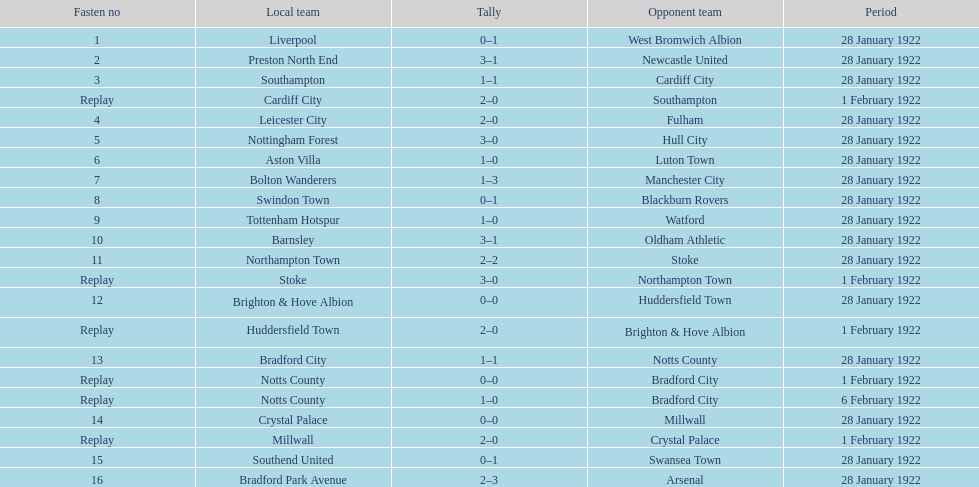What are all of the home teams? Liverpool, Preston North End, Southampton, Cardiff City, Leicester City, Nottingham Forest, Aston Villa, Bolton Wanderers, Swindon Town, Tottenham Hotspur, Barnsley, Northampton Town, Stoke, Brighton & Hove Albion, Huddersfield Town, Bradford City, Notts County, Notts County, Crystal Palace, Millwall, Southend United, Bradford Park Avenue. Could you parse the entire table? {'header': ['Fasten no', 'Local team', 'Tally', 'Opponent team', 'Period'], 'rows': [['1', 'Liverpool', '0–1', 'West Bromwich Albion', '28 January 1922'], ['2', 'Preston North End', '3–1', 'Newcastle United', '28 January 1922'], ['3', 'Southampton', '1–1', 'Cardiff City', '28 January 1922'], ['Replay', 'Cardiff City', '2–0', 'Southampton', '1 February 1922'], ['4', 'Leicester City', '2–0', 'Fulham', '28 January 1922'], ['5', 'Nottingham Forest', '3–0', 'Hull City', '28 January 1922'], ['6', 'Aston Villa', '1–0', 'Luton Town', '28 January 1922'], ['7', 'Bolton Wanderers', '1–3', 'Manchester City', '28 January 1922'], ['8', 'Swindon Town', '0–1', 'Blackburn Rovers', '28 January 1922'], ['9', 'Tottenham Hotspur', '1–0', 'Watford', '28 January 1922'], ['10', 'Barnsley', '3–1', 'Oldham Athletic', '28 January 1922'], ['11', 'Northampton Town', '2–2', 'Stoke', '28 January 1922'], ['Replay', 'Stoke', '3–0', 'Northampton Town', '1 February 1922'], ['12', 'Brighton & Hove Albion', '0–0', 'Huddersfield Town', '28 January 1922'], ['Replay', 'Huddersfield Town', '2–0', 'Brighton & Hove Albion', '1 February 1922'], ['13', 'Bradford City', '1–1', 'Notts County', '28 January 1922'], ['Replay', 'Notts County', '0–0', 'Bradford City', '1 February 1922'], ['Replay', 'Notts County', '1–0', 'Bradford City', '6 February 1922'], ['14', 'Crystal Palace', '0–0', 'Millwall', '28 January 1922'], ['Replay', 'Millwall', '2–0', 'Crystal Palace', '1 February 1922'], ['15', 'Southend United', '0–1', 'Swansea Town', '28 January 1922'], ['16', 'Bradford Park Avenue', '2–3', 'Arsenal', '28 January 1922']]} What were the scores? 0–1, 3–1, 1–1, 2–0, 2–0, 3–0, 1–0, 1–3, 0–1, 1–0, 3–1, 2–2, 3–0, 0–0, 2–0, 1–1, 0–0, 1–0, 0–0, 2–0, 0–1, 2–3. On which dates did they play? 28 January 1922, 28 January 1922, 28 January 1922, 1 February 1922, 28 January 1922, 28 January 1922, 28 January 1922, 28 January 1922, 28 January 1922, 28 January 1922, 28 January 1922, 28 January 1922, 1 February 1922, 28 January 1922, 1 February 1922, 28 January 1922, 1 February 1922, 6 February 1922, 28 January 1922, 1 February 1922, 28 January 1922, 28 January 1922. Which teams played on 28 january 1922? Liverpool, Preston North End, Southampton, Leicester City, Nottingham Forest, Aston Villa, Bolton Wanderers, Swindon Town, Tottenham Hotspur, Barnsley, Northampton Town, Brighton & Hove Albion, Bradford City, Crystal Palace, Southend United, Bradford Park Avenue. Of those, which scored the same as aston villa? Tottenham Hotspur. 